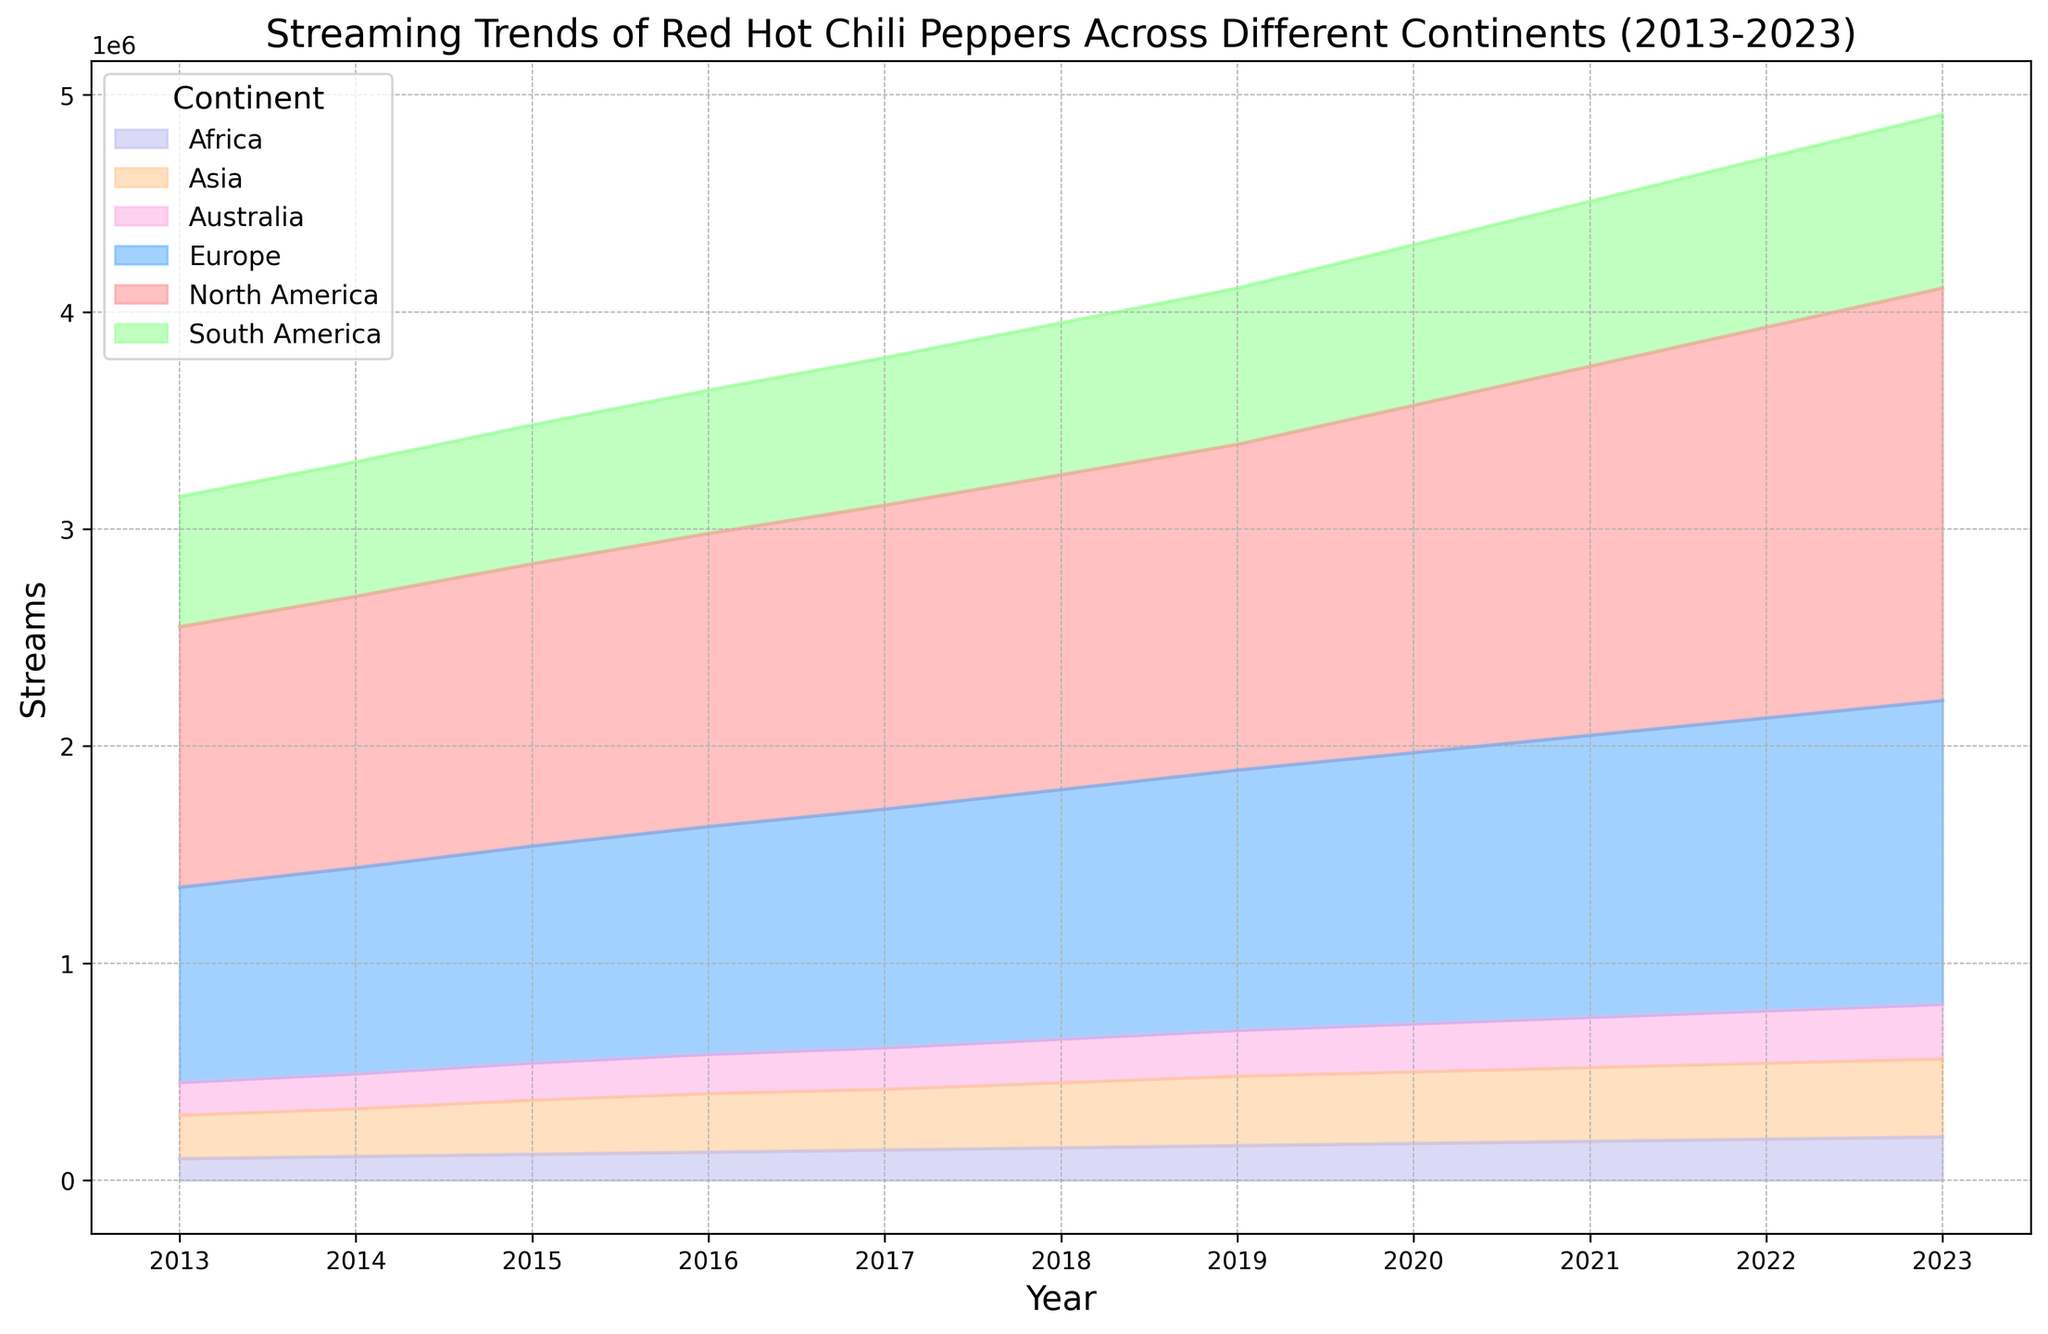Which continent had the highest number of streams in 2022? Look at the year 2022 on the x-axis and compare the heights of the colored areas. North America has the highest vertical height, indicating it has the most streams.
Answer: North America Which continents have consistently shown an increasing trend in streams from 2013 to 2023? Observe each colored area and note their general direction from 2013 to 2023. North America and Europe show a consistent upward trend without any dips.
Answer: North America, Europe What is the approximate difference in the number of streams between North America and South America in 2020? Refer to the heights of the North America and South America areas in 2020 and subtract the streams of South America from North America. North America appears to have around 1,600,000 streams, and South America around 740,000. Therefore, the difference is roughly 1,600,000 - 740,000 = 860,000.
Answer: 860,000 How many continents had over 1,000,000 streams by the end of 2023? Check the height of each area in 2023. North America, Europe, and no other continents exceed the 1,000,000 mark.
Answer: 2 Compare the changes in streams of Asia and Australia from 2015 to 2018. Which continent experienced a faster increase in streams? Observe the slopes of the areas for Asia and Australia between 2015 and 2018. Asia's area increased from approximately 250,000 to 300,000 (a 50,000 increase), while Australia increased from around 170,000 to 200,000 (a 30,000 increase). Asia had a faster increase.
Answer: Asia What is the cumulative increase in streams for Europe from 2015 to 2020? Calculate the difference in streams at the year 2015 and 2020 for Europe. In 2015, Europe had approximately 1,000,000 streams and in 2020, about 1,250,000 streams. The cumulative increase is 1,250,000 - 1,000,000 = 250,000.
Answer: 250,000 Which continent shows the least variation in streams over the years? Variations can be observed by looking at how flat or stable the areas are. Africa's area shows the least change with a relatively stable height around the low hundreds, indicating the least variation.
Answer: Africa What is the sum of streams for Asia and Africa in 2019? Find the streams for Asia (around 320,000) and Africa (around 160,000) in the year 2019 and add them up. The sum is 320,000 + 160,000 = 480,000.
Answer: 480,000 How does the proportion of streams in South America compare to Europe in 2016? Observe the relative heights of the South America and Europe areas in 2016. Europe has over 1,000,000 streams while South America has around 660,000. South America's streams are roughly 66% of Europe's streams that year.
Answer: 66% By how much did the streams in Africa increase from 2017 to 2023? Look at the height of Africa's area at 2017 and 2023. In 2017, streams are at approximately 140,000 and in 2023 at 200,000. The increase is 200,000 - 140,000 = 60,000.
Answer: 60,000 